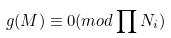Convert formula to latex. <formula><loc_0><loc_0><loc_500><loc_500>g ( M ) \equiv 0 ( m o d \prod N _ { i } )</formula> 